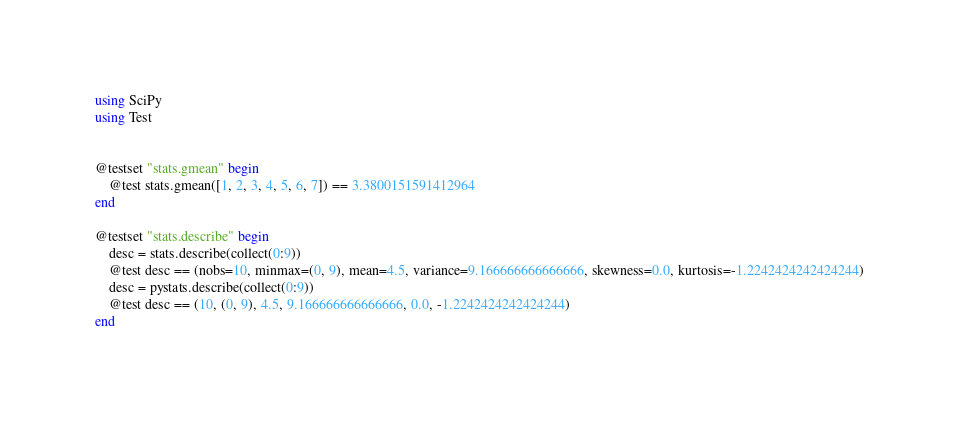Convert code to text. <code><loc_0><loc_0><loc_500><loc_500><_Julia_>using SciPy
using Test


@testset "stats.gmean" begin
    @test stats.gmean([1, 2, 3, 4, 5, 6, 7]) == 3.3800151591412964
end

@testset "stats.describe" begin
    desc = stats.describe(collect(0:9))
    @test desc == (nobs=10, minmax=(0, 9), mean=4.5, variance=9.166666666666666, skewness=0.0, kurtosis=-1.2242424242424244)
    desc = pystats.describe(collect(0:9))
    @test desc == (10, (0, 9), 4.5, 9.166666666666666, 0.0, -1.2242424242424244)
end


</code> 